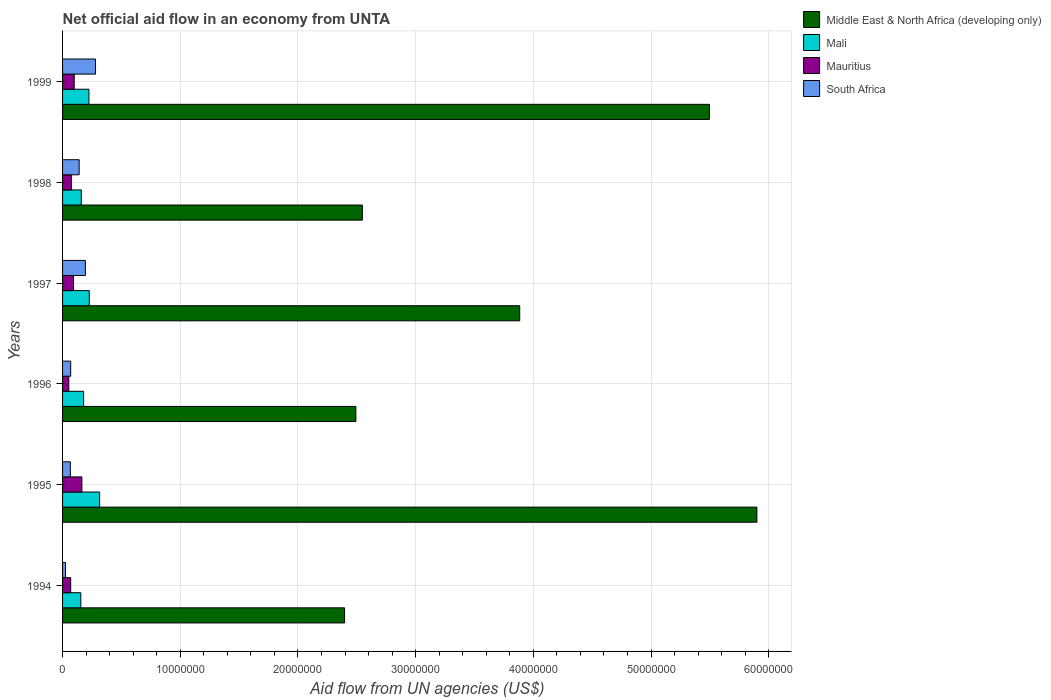How many groups of bars are there?
Your answer should be very brief. 6. Are the number of bars per tick equal to the number of legend labels?
Your answer should be compact. Yes. Are the number of bars on each tick of the Y-axis equal?
Your response must be concise. Yes. How many bars are there on the 4th tick from the top?
Ensure brevity in your answer.  4. In how many cases, is the number of bars for a given year not equal to the number of legend labels?
Provide a short and direct response. 0. What is the net official aid flow in Middle East & North Africa (developing only) in 1994?
Keep it short and to the point. 2.40e+07. Across all years, what is the maximum net official aid flow in South Africa?
Give a very brief answer. 2.80e+06. Across all years, what is the minimum net official aid flow in Mali?
Keep it short and to the point. 1.55e+06. In which year was the net official aid flow in Middle East & North Africa (developing only) maximum?
Make the answer very short. 1995. What is the total net official aid flow in Mauritius in the graph?
Offer a very short reply. 5.53e+06. What is the difference between the net official aid flow in South Africa in 1994 and that in 1998?
Ensure brevity in your answer.  -1.16e+06. What is the difference between the net official aid flow in Mauritius in 1996 and the net official aid flow in South Africa in 1999?
Your answer should be compact. -2.27e+06. What is the average net official aid flow in Middle East & North Africa (developing only) per year?
Provide a succinct answer. 3.79e+07. In the year 1996, what is the difference between the net official aid flow in Middle East & North Africa (developing only) and net official aid flow in South Africa?
Ensure brevity in your answer.  2.42e+07. What is the ratio of the net official aid flow in Mauritius in 1995 to that in 1997?
Provide a succinct answer. 1.76. Is the net official aid flow in Mauritius in 1994 less than that in 1998?
Give a very brief answer. Yes. What is the difference between the highest and the second highest net official aid flow in Middle East & North Africa (developing only)?
Your answer should be compact. 4.03e+06. What is the difference between the highest and the lowest net official aid flow in Mali?
Your answer should be compact. 1.60e+06. In how many years, is the net official aid flow in Middle East & North Africa (developing only) greater than the average net official aid flow in Middle East & North Africa (developing only) taken over all years?
Provide a succinct answer. 3. What does the 1st bar from the top in 1999 represents?
Keep it short and to the point. South Africa. What does the 4th bar from the bottom in 1999 represents?
Offer a very short reply. South Africa. How many years are there in the graph?
Offer a very short reply. 6. What is the difference between two consecutive major ticks on the X-axis?
Give a very brief answer. 1.00e+07. Are the values on the major ticks of X-axis written in scientific E-notation?
Keep it short and to the point. No. How many legend labels are there?
Provide a succinct answer. 4. How are the legend labels stacked?
Provide a short and direct response. Vertical. What is the title of the graph?
Make the answer very short. Net official aid flow in an economy from UNTA. What is the label or title of the X-axis?
Provide a succinct answer. Aid flow from UN agencies (US$). What is the label or title of the Y-axis?
Your answer should be very brief. Years. What is the Aid flow from UN agencies (US$) of Middle East & North Africa (developing only) in 1994?
Give a very brief answer. 2.40e+07. What is the Aid flow from UN agencies (US$) in Mali in 1994?
Provide a succinct answer. 1.55e+06. What is the Aid flow from UN agencies (US$) of Mauritius in 1994?
Make the answer very short. 6.90e+05. What is the Aid flow from UN agencies (US$) of South Africa in 1994?
Provide a succinct answer. 2.50e+05. What is the Aid flow from UN agencies (US$) in Middle East & North Africa (developing only) in 1995?
Make the answer very short. 5.90e+07. What is the Aid flow from UN agencies (US$) in Mali in 1995?
Keep it short and to the point. 3.15e+06. What is the Aid flow from UN agencies (US$) in Mauritius in 1995?
Provide a short and direct response. 1.64e+06. What is the Aid flow from UN agencies (US$) in South Africa in 1995?
Your answer should be compact. 6.60e+05. What is the Aid flow from UN agencies (US$) in Middle East & North Africa (developing only) in 1996?
Provide a succinct answer. 2.49e+07. What is the Aid flow from UN agencies (US$) in Mali in 1996?
Offer a terse response. 1.79e+06. What is the Aid flow from UN agencies (US$) of Mauritius in 1996?
Give a very brief answer. 5.30e+05. What is the Aid flow from UN agencies (US$) of South Africa in 1996?
Your answer should be very brief. 6.90e+05. What is the Aid flow from UN agencies (US$) of Middle East & North Africa (developing only) in 1997?
Your answer should be very brief. 3.88e+07. What is the Aid flow from UN agencies (US$) of Mali in 1997?
Make the answer very short. 2.27e+06. What is the Aid flow from UN agencies (US$) in Mauritius in 1997?
Keep it short and to the point. 9.30e+05. What is the Aid flow from UN agencies (US$) in South Africa in 1997?
Offer a terse response. 1.94e+06. What is the Aid flow from UN agencies (US$) of Middle East & North Africa (developing only) in 1998?
Keep it short and to the point. 2.55e+07. What is the Aid flow from UN agencies (US$) of Mali in 1998?
Provide a succinct answer. 1.59e+06. What is the Aid flow from UN agencies (US$) in Mauritius in 1998?
Your answer should be very brief. 7.50e+05. What is the Aid flow from UN agencies (US$) in South Africa in 1998?
Offer a very short reply. 1.41e+06. What is the Aid flow from UN agencies (US$) of Middle East & North Africa (developing only) in 1999?
Offer a very short reply. 5.50e+07. What is the Aid flow from UN agencies (US$) of Mali in 1999?
Make the answer very short. 2.24e+06. What is the Aid flow from UN agencies (US$) of Mauritius in 1999?
Provide a succinct answer. 9.90e+05. What is the Aid flow from UN agencies (US$) of South Africa in 1999?
Your answer should be compact. 2.80e+06. Across all years, what is the maximum Aid flow from UN agencies (US$) of Middle East & North Africa (developing only)?
Ensure brevity in your answer.  5.90e+07. Across all years, what is the maximum Aid flow from UN agencies (US$) in Mali?
Offer a very short reply. 3.15e+06. Across all years, what is the maximum Aid flow from UN agencies (US$) of Mauritius?
Offer a very short reply. 1.64e+06. Across all years, what is the maximum Aid flow from UN agencies (US$) of South Africa?
Your response must be concise. 2.80e+06. Across all years, what is the minimum Aid flow from UN agencies (US$) of Middle East & North Africa (developing only)?
Your response must be concise. 2.40e+07. Across all years, what is the minimum Aid flow from UN agencies (US$) of Mali?
Give a very brief answer. 1.55e+06. Across all years, what is the minimum Aid flow from UN agencies (US$) of Mauritius?
Make the answer very short. 5.30e+05. Across all years, what is the minimum Aid flow from UN agencies (US$) in South Africa?
Provide a succinct answer. 2.50e+05. What is the total Aid flow from UN agencies (US$) in Middle East & North Africa (developing only) in the graph?
Ensure brevity in your answer.  2.27e+08. What is the total Aid flow from UN agencies (US$) of Mali in the graph?
Your answer should be compact. 1.26e+07. What is the total Aid flow from UN agencies (US$) of Mauritius in the graph?
Provide a short and direct response. 5.53e+06. What is the total Aid flow from UN agencies (US$) of South Africa in the graph?
Your answer should be compact. 7.75e+06. What is the difference between the Aid flow from UN agencies (US$) of Middle East & North Africa (developing only) in 1994 and that in 1995?
Make the answer very short. -3.50e+07. What is the difference between the Aid flow from UN agencies (US$) of Mali in 1994 and that in 1995?
Your answer should be very brief. -1.60e+06. What is the difference between the Aid flow from UN agencies (US$) in Mauritius in 1994 and that in 1995?
Make the answer very short. -9.50e+05. What is the difference between the Aid flow from UN agencies (US$) in South Africa in 1994 and that in 1995?
Your answer should be very brief. -4.10e+05. What is the difference between the Aid flow from UN agencies (US$) in Middle East & North Africa (developing only) in 1994 and that in 1996?
Offer a terse response. -9.60e+05. What is the difference between the Aid flow from UN agencies (US$) in Mali in 1994 and that in 1996?
Your answer should be compact. -2.40e+05. What is the difference between the Aid flow from UN agencies (US$) in Mauritius in 1994 and that in 1996?
Give a very brief answer. 1.60e+05. What is the difference between the Aid flow from UN agencies (US$) of South Africa in 1994 and that in 1996?
Offer a very short reply. -4.40e+05. What is the difference between the Aid flow from UN agencies (US$) of Middle East & North Africa (developing only) in 1994 and that in 1997?
Keep it short and to the point. -1.49e+07. What is the difference between the Aid flow from UN agencies (US$) of Mali in 1994 and that in 1997?
Your answer should be compact. -7.20e+05. What is the difference between the Aid flow from UN agencies (US$) of South Africa in 1994 and that in 1997?
Provide a succinct answer. -1.69e+06. What is the difference between the Aid flow from UN agencies (US$) of Middle East & North Africa (developing only) in 1994 and that in 1998?
Keep it short and to the point. -1.51e+06. What is the difference between the Aid flow from UN agencies (US$) in South Africa in 1994 and that in 1998?
Offer a very short reply. -1.16e+06. What is the difference between the Aid flow from UN agencies (US$) of Middle East & North Africa (developing only) in 1994 and that in 1999?
Keep it short and to the point. -3.10e+07. What is the difference between the Aid flow from UN agencies (US$) in Mali in 1994 and that in 1999?
Provide a short and direct response. -6.90e+05. What is the difference between the Aid flow from UN agencies (US$) of South Africa in 1994 and that in 1999?
Offer a terse response. -2.55e+06. What is the difference between the Aid flow from UN agencies (US$) of Middle East & North Africa (developing only) in 1995 and that in 1996?
Provide a short and direct response. 3.41e+07. What is the difference between the Aid flow from UN agencies (US$) of Mali in 1995 and that in 1996?
Offer a very short reply. 1.36e+06. What is the difference between the Aid flow from UN agencies (US$) in Mauritius in 1995 and that in 1996?
Provide a short and direct response. 1.11e+06. What is the difference between the Aid flow from UN agencies (US$) in Middle East & North Africa (developing only) in 1995 and that in 1997?
Give a very brief answer. 2.02e+07. What is the difference between the Aid flow from UN agencies (US$) in Mali in 1995 and that in 1997?
Provide a short and direct response. 8.80e+05. What is the difference between the Aid flow from UN agencies (US$) of Mauritius in 1995 and that in 1997?
Your response must be concise. 7.10e+05. What is the difference between the Aid flow from UN agencies (US$) in South Africa in 1995 and that in 1997?
Keep it short and to the point. -1.28e+06. What is the difference between the Aid flow from UN agencies (US$) of Middle East & North Africa (developing only) in 1995 and that in 1998?
Make the answer very short. 3.35e+07. What is the difference between the Aid flow from UN agencies (US$) of Mali in 1995 and that in 1998?
Offer a terse response. 1.56e+06. What is the difference between the Aid flow from UN agencies (US$) of Mauritius in 1995 and that in 1998?
Offer a very short reply. 8.90e+05. What is the difference between the Aid flow from UN agencies (US$) in South Africa in 1995 and that in 1998?
Make the answer very short. -7.50e+05. What is the difference between the Aid flow from UN agencies (US$) in Middle East & North Africa (developing only) in 1995 and that in 1999?
Your response must be concise. 4.03e+06. What is the difference between the Aid flow from UN agencies (US$) in Mali in 1995 and that in 1999?
Your response must be concise. 9.10e+05. What is the difference between the Aid flow from UN agencies (US$) of Mauritius in 1995 and that in 1999?
Provide a short and direct response. 6.50e+05. What is the difference between the Aid flow from UN agencies (US$) in South Africa in 1995 and that in 1999?
Provide a succinct answer. -2.14e+06. What is the difference between the Aid flow from UN agencies (US$) in Middle East & North Africa (developing only) in 1996 and that in 1997?
Provide a succinct answer. -1.39e+07. What is the difference between the Aid flow from UN agencies (US$) in Mali in 1996 and that in 1997?
Your answer should be compact. -4.80e+05. What is the difference between the Aid flow from UN agencies (US$) in Mauritius in 1996 and that in 1997?
Your response must be concise. -4.00e+05. What is the difference between the Aid flow from UN agencies (US$) of South Africa in 1996 and that in 1997?
Your answer should be compact. -1.25e+06. What is the difference between the Aid flow from UN agencies (US$) of Middle East & North Africa (developing only) in 1996 and that in 1998?
Your response must be concise. -5.50e+05. What is the difference between the Aid flow from UN agencies (US$) of Mauritius in 1996 and that in 1998?
Your answer should be compact. -2.20e+05. What is the difference between the Aid flow from UN agencies (US$) of South Africa in 1996 and that in 1998?
Give a very brief answer. -7.20e+05. What is the difference between the Aid flow from UN agencies (US$) of Middle East & North Africa (developing only) in 1996 and that in 1999?
Provide a succinct answer. -3.00e+07. What is the difference between the Aid flow from UN agencies (US$) in Mali in 1996 and that in 1999?
Your response must be concise. -4.50e+05. What is the difference between the Aid flow from UN agencies (US$) of Mauritius in 1996 and that in 1999?
Your response must be concise. -4.60e+05. What is the difference between the Aid flow from UN agencies (US$) of South Africa in 1996 and that in 1999?
Ensure brevity in your answer.  -2.11e+06. What is the difference between the Aid flow from UN agencies (US$) of Middle East & North Africa (developing only) in 1997 and that in 1998?
Offer a very short reply. 1.34e+07. What is the difference between the Aid flow from UN agencies (US$) of Mali in 1997 and that in 1998?
Ensure brevity in your answer.  6.80e+05. What is the difference between the Aid flow from UN agencies (US$) in Mauritius in 1997 and that in 1998?
Offer a very short reply. 1.80e+05. What is the difference between the Aid flow from UN agencies (US$) in South Africa in 1997 and that in 1998?
Your response must be concise. 5.30e+05. What is the difference between the Aid flow from UN agencies (US$) in Middle East & North Africa (developing only) in 1997 and that in 1999?
Ensure brevity in your answer.  -1.61e+07. What is the difference between the Aid flow from UN agencies (US$) in Mauritius in 1997 and that in 1999?
Offer a very short reply. -6.00e+04. What is the difference between the Aid flow from UN agencies (US$) in South Africa in 1997 and that in 1999?
Keep it short and to the point. -8.60e+05. What is the difference between the Aid flow from UN agencies (US$) in Middle East & North Africa (developing only) in 1998 and that in 1999?
Offer a very short reply. -2.95e+07. What is the difference between the Aid flow from UN agencies (US$) in Mali in 1998 and that in 1999?
Give a very brief answer. -6.50e+05. What is the difference between the Aid flow from UN agencies (US$) of Mauritius in 1998 and that in 1999?
Make the answer very short. -2.40e+05. What is the difference between the Aid flow from UN agencies (US$) of South Africa in 1998 and that in 1999?
Your answer should be very brief. -1.39e+06. What is the difference between the Aid flow from UN agencies (US$) of Middle East & North Africa (developing only) in 1994 and the Aid flow from UN agencies (US$) of Mali in 1995?
Give a very brief answer. 2.08e+07. What is the difference between the Aid flow from UN agencies (US$) in Middle East & North Africa (developing only) in 1994 and the Aid flow from UN agencies (US$) in Mauritius in 1995?
Offer a very short reply. 2.23e+07. What is the difference between the Aid flow from UN agencies (US$) of Middle East & North Africa (developing only) in 1994 and the Aid flow from UN agencies (US$) of South Africa in 1995?
Offer a terse response. 2.33e+07. What is the difference between the Aid flow from UN agencies (US$) in Mali in 1994 and the Aid flow from UN agencies (US$) in South Africa in 1995?
Ensure brevity in your answer.  8.90e+05. What is the difference between the Aid flow from UN agencies (US$) of Middle East & North Africa (developing only) in 1994 and the Aid flow from UN agencies (US$) of Mali in 1996?
Give a very brief answer. 2.22e+07. What is the difference between the Aid flow from UN agencies (US$) in Middle East & North Africa (developing only) in 1994 and the Aid flow from UN agencies (US$) in Mauritius in 1996?
Your answer should be compact. 2.34e+07. What is the difference between the Aid flow from UN agencies (US$) in Middle East & North Africa (developing only) in 1994 and the Aid flow from UN agencies (US$) in South Africa in 1996?
Make the answer very short. 2.33e+07. What is the difference between the Aid flow from UN agencies (US$) in Mali in 1994 and the Aid flow from UN agencies (US$) in Mauritius in 1996?
Provide a short and direct response. 1.02e+06. What is the difference between the Aid flow from UN agencies (US$) in Mali in 1994 and the Aid flow from UN agencies (US$) in South Africa in 1996?
Your answer should be compact. 8.60e+05. What is the difference between the Aid flow from UN agencies (US$) of Middle East & North Africa (developing only) in 1994 and the Aid flow from UN agencies (US$) of Mali in 1997?
Offer a terse response. 2.17e+07. What is the difference between the Aid flow from UN agencies (US$) in Middle East & North Africa (developing only) in 1994 and the Aid flow from UN agencies (US$) in Mauritius in 1997?
Your response must be concise. 2.30e+07. What is the difference between the Aid flow from UN agencies (US$) of Middle East & North Africa (developing only) in 1994 and the Aid flow from UN agencies (US$) of South Africa in 1997?
Your response must be concise. 2.20e+07. What is the difference between the Aid flow from UN agencies (US$) in Mali in 1994 and the Aid flow from UN agencies (US$) in Mauritius in 1997?
Your answer should be compact. 6.20e+05. What is the difference between the Aid flow from UN agencies (US$) in Mali in 1994 and the Aid flow from UN agencies (US$) in South Africa in 1997?
Your answer should be very brief. -3.90e+05. What is the difference between the Aid flow from UN agencies (US$) in Mauritius in 1994 and the Aid flow from UN agencies (US$) in South Africa in 1997?
Keep it short and to the point. -1.25e+06. What is the difference between the Aid flow from UN agencies (US$) in Middle East & North Africa (developing only) in 1994 and the Aid flow from UN agencies (US$) in Mali in 1998?
Offer a terse response. 2.24e+07. What is the difference between the Aid flow from UN agencies (US$) of Middle East & North Africa (developing only) in 1994 and the Aid flow from UN agencies (US$) of Mauritius in 1998?
Your response must be concise. 2.32e+07. What is the difference between the Aid flow from UN agencies (US$) in Middle East & North Africa (developing only) in 1994 and the Aid flow from UN agencies (US$) in South Africa in 1998?
Provide a succinct answer. 2.26e+07. What is the difference between the Aid flow from UN agencies (US$) in Mali in 1994 and the Aid flow from UN agencies (US$) in Mauritius in 1998?
Provide a short and direct response. 8.00e+05. What is the difference between the Aid flow from UN agencies (US$) of Mali in 1994 and the Aid flow from UN agencies (US$) of South Africa in 1998?
Give a very brief answer. 1.40e+05. What is the difference between the Aid flow from UN agencies (US$) in Mauritius in 1994 and the Aid flow from UN agencies (US$) in South Africa in 1998?
Give a very brief answer. -7.20e+05. What is the difference between the Aid flow from UN agencies (US$) of Middle East & North Africa (developing only) in 1994 and the Aid flow from UN agencies (US$) of Mali in 1999?
Your answer should be compact. 2.17e+07. What is the difference between the Aid flow from UN agencies (US$) in Middle East & North Africa (developing only) in 1994 and the Aid flow from UN agencies (US$) in Mauritius in 1999?
Ensure brevity in your answer.  2.30e+07. What is the difference between the Aid flow from UN agencies (US$) of Middle East & North Africa (developing only) in 1994 and the Aid flow from UN agencies (US$) of South Africa in 1999?
Your answer should be compact. 2.12e+07. What is the difference between the Aid flow from UN agencies (US$) of Mali in 1994 and the Aid flow from UN agencies (US$) of Mauritius in 1999?
Provide a succinct answer. 5.60e+05. What is the difference between the Aid flow from UN agencies (US$) of Mali in 1994 and the Aid flow from UN agencies (US$) of South Africa in 1999?
Make the answer very short. -1.25e+06. What is the difference between the Aid flow from UN agencies (US$) in Mauritius in 1994 and the Aid flow from UN agencies (US$) in South Africa in 1999?
Your response must be concise. -2.11e+06. What is the difference between the Aid flow from UN agencies (US$) of Middle East & North Africa (developing only) in 1995 and the Aid flow from UN agencies (US$) of Mali in 1996?
Offer a very short reply. 5.72e+07. What is the difference between the Aid flow from UN agencies (US$) of Middle East & North Africa (developing only) in 1995 and the Aid flow from UN agencies (US$) of Mauritius in 1996?
Offer a very short reply. 5.85e+07. What is the difference between the Aid flow from UN agencies (US$) in Middle East & North Africa (developing only) in 1995 and the Aid flow from UN agencies (US$) in South Africa in 1996?
Give a very brief answer. 5.83e+07. What is the difference between the Aid flow from UN agencies (US$) in Mali in 1995 and the Aid flow from UN agencies (US$) in Mauritius in 1996?
Ensure brevity in your answer.  2.62e+06. What is the difference between the Aid flow from UN agencies (US$) of Mali in 1995 and the Aid flow from UN agencies (US$) of South Africa in 1996?
Make the answer very short. 2.46e+06. What is the difference between the Aid flow from UN agencies (US$) in Mauritius in 1995 and the Aid flow from UN agencies (US$) in South Africa in 1996?
Your answer should be compact. 9.50e+05. What is the difference between the Aid flow from UN agencies (US$) in Middle East & North Africa (developing only) in 1995 and the Aid flow from UN agencies (US$) in Mali in 1997?
Provide a succinct answer. 5.67e+07. What is the difference between the Aid flow from UN agencies (US$) in Middle East & North Africa (developing only) in 1995 and the Aid flow from UN agencies (US$) in Mauritius in 1997?
Your answer should be compact. 5.81e+07. What is the difference between the Aid flow from UN agencies (US$) of Middle East & North Africa (developing only) in 1995 and the Aid flow from UN agencies (US$) of South Africa in 1997?
Give a very brief answer. 5.70e+07. What is the difference between the Aid flow from UN agencies (US$) of Mali in 1995 and the Aid flow from UN agencies (US$) of Mauritius in 1997?
Your answer should be very brief. 2.22e+06. What is the difference between the Aid flow from UN agencies (US$) of Mali in 1995 and the Aid flow from UN agencies (US$) of South Africa in 1997?
Make the answer very short. 1.21e+06. What is the difference between the Aid flow from UN agencies (US$) in Middle East & North Africa (developing only) in 1995 and the Aid flow from UN agencies (US$) in Mali in 1998?
Offer a terse response. 5.74e+07. What is the difference between the Aid flow from UN agencies (US$) of Middle East & North Africa (developing only) in 1995 and the Aid flow from UN agencies (US$) of Mauritius in 1998?
Your answer should be very brief. 5.82e+07. What is the difference between the Aid flow from UN agencies (US$) in Middle East & North Africa (developing only) in 1995 and the Aid flow from UN agencies (US$) in South Africa in 1998?
Your answer should be very brief. 5.76e+07. What is the difference between the Aid flow from UN agencies (US$) in Mali in 1995 and the Aid flow from UN agencies (US$) in Mauritius in 1998?
Your response must be concise. 2.40e+06. What is the difference between the Aid flow from UN agencies (US$) in Mali in 1995 and the Aid flow from UN agencies (US$) in South Africa in 1998?
Keep it short and to the point. 1.74e+06. What is the difference between the Aid flow from UN agencies (US$) in Middle East & North Africa (developing only) in 1995 and the Aid flow from UN agencies (US$) in Mali in 1999?
Your answer should be very brief. 5.68e+07. What is the difference between the Aid flow from UN agencies (US$) of Middle East & North Africa (developing only) in 1995 and the Aid flow from UN agencies (US$) of Mauritius in 1999?
Your answer should be compact. 5.80e+07. What is the difference between the Aid flow from UN agencies (US$) in Middle East & North Africa (developing only) in 1995 and the Aid flow from UN agencies (US$) in South Africa in 1999?
Ensure brevity in your answer.  5.62e+07. What is the difference between the Aid flow from UN agencies (US$) in Mali in 1995 and the Aid flow from UN agencies (US$) in Mauritius in 1999?
Provide a short and direct response. 2.16e+06. What is the difference between the Aid flow from UN agencies (US$) in Mauritius in 1995 and the Aid flow from UN agencies (US$) in South Africa in 1999?
Ensure brevity in your answer.  -1.16e+06. What is the difference between the Aid flow from UN agencies (US$) in Middle East & North Africa (developing only) in 1996 and the Aid flow from UN agencies (US$) in Mali in 1997?
Your response must be concise. 2.26e+07. What is the difference between the Aid flow from UN agencies (US$) in Middle East & North Africa (developing only) in 1996 and the Aid flow from UN agencies (US$) in Mauritius in 1997?
Keep it short and to the point. 2.40e+07. What is the difference between the Aid flow from UN agencies (US$) in Middle East & North Africa (developing only) in 1996 and the Aid flow from UN agencies (US$) in South Africa in 1997?
Provide a succinct answer. 2.30e+07. What is the difference between the Aid flow from UN agencies (US$) in Mali in 1996 and the Aid flow from UN agencies (US$) in Mauritius in 1997?
Offer a very short reply. 8.60e+05. What is the difference between the Aid flow from UN agencies (US$) in Mauritius in 1996 and the Aid flow from UN agencies (US$) in South Africa in 1997?
Keep it short and to the point. -1.41e+06. What is the difference between the Aid flow from UN agencies (US$) of Middle East & North Africa (developing only) in 1996 and the Aid flow from UN agencies (US$) of Mali in 1998?
Ensure brevity in your answer.  2.33e+07. What is the difference between the Aid flow from UN agencies (US$) in Middle East & North Africa (developing only) in 1996 and the Aid flow from UN agencies (US$) in Mauritius in 1998?
Provide a succinct answer. 2.42e+07. What is the difference between the Aid flow from UN agencies (US$) in Middle East & North Africa (developing only) in 1996 and the Aid flow from UN agencies (US$) in South Africa in 1998?
Give a very brief answer. 2.35e+07. What is the difference between the Aid flow from UN agencies (US$) of Mali in 1996 and the Aid flow from UN agencies (US$) of Mauritius in 1998?
Make the answer very short. 1.04e+06. What is the difference between the Aid flow from UN agencies (US$) of Mali in 1996 and the Aid flow from UN agencies (US$) of South Africa in 1998?
Offer a terse response. 3.80e+05. What is the difference between the Aid flow from UN agencies (US$) in Mauritius in 1996 and the Aid flow from UN agencies (US$) in South Africa in 1998?
Give a very brief answer. -8.80e+05. What is the difference between the Aid flow from UN agencies (US$) in Middle East & North Africa (developing only) in 1996 and the Aid flow from UN agencies (US$) in Mali in 1999?
Provide a succinct answer. 2.27e+07. What is the difference between the Aid flow from UN agencies (US$) of Middle East & North Africa (developing only) in 1996 and the Aid flow from UN agencies (US$) of Mauritius in 1999?
Your answer should be compact. 2.39e+07. What is the difference between the Aid flow from UN agencies (US$) of Middle East & North Africa (developing only) in 1996 and the Aid flow from UN agencies (US$) of South Africa in 1999?
Keep it short and to the point. 2.21e+07. What is the difference between the Aid flow from UN agencies (US$) of Mali in 1996 and the Aid flow from UN agencies (US$) of South Africa in 1999?
Your answer should be compact. -1.01e+06. What is the difference between the Aid flow from UN agencies (US$) in Mauritius in 1996 and the Aid flow from UN agencies (US$) in South Africa in 1999?
Your response must be concise. -2.27e+06. What is the difference between the Aid flow from UN agencies (US$) in Middle East & North Africa (developing only) in 1997 and the Aid flow from UN agencies (US$) in Mali in 1998?
Provide a succinct answer. 3.72e+07. What is the difference between the Aid flow from UN agencies (US$) of Middle East & North Africa (developing only) in 1997 and the Aid flow from UN agencies (US$) of Mauritius in 1998?
Give a very brief answer. 3.81e+07. What is the difference between the Aid flow from UN agencies (US$) in Middle East & North Africa (developing only) in 1997 and the Aid flow from UN agencies (US$) in South Africa in 1998?
Offer a very short reply. 3.74e+07. What is the difference between the Aid flow from UN agencies (US$) in Mali in 1997 and the Aid flow from UN agencies (US$) in Mauritius in 1998?
Make the answer very short. 1.52e+06. What is the difference between the Aid flow from UN agencies (US$) in Mali in 1997 and the Aid flow from UN agencies (US$) in South Africa in 1998?
Provide a succinct answer. 8.60e+05. What is the difference between the Aid flow from UN agencies (US$) of Mauritius in 1997 and the Aid flow from UN agencies (US$) of South Africa in 1998?
Ensure brevity in your answer.  -4.80e+05. What is the difference between the Aid flow from UN agencies (US$) of Middle East & North Africa (developing only) in 1997 and the Aid flow from UN agencies (US$) of Mali in 1999?
Ensure brevity in your answer.  3.66e+07. What is the difference between the Aid flow from UN agencies (US$) in Middle East & North Africa (developing only) in 1997 and the Aid flow from UN agencies (US$) in Mauritius in 1999?
Provide a short and direct response. 3.78e+07. What is the difference between the Aid flow from UN agencies (US$) of Middle East & North Africa (developing only) in 1997 and the Aid flow from UN agencies (US$) of South Africa in 1999?
Your answer should be compact. 3.60e+07. What is the difference between the Aid flow from UN agencies (US$) in Mali in 1997 and the Aid flow from UN agencies (US$) in Mauritius in 1999?
Your response must be concise. 1.28e+06. What is the difference between the Aid flow from UN agencies (US$) of Mali in 1997 and the Aid flow from UN agencies (US$) of South Africa in 1999?
Provide a succinct answer. -5.30e+05. What is the difference between the Aid flow from UN agencies (US$) of Mauritius in 1997 and the Aid flow from UN agencies (US$) of South Africa in 1999?
Offer a very short reply. -1.87e+06. What is the difference between the Aid flow from UN agencies (US$) in Middle East & North Africa (developing only) in 1998 and the Aid flow from UN agencies (US$) in Mali in 1999?
Your answer should be very brief. 2.32e+07. What is the difference between the Aid flow from UN agencies (US$) in Middle East & North Africa (developing only) in 1998 and the Aid flow from UN agencies (US$) in Mauritius in 1999?
Your answer should be very brief. 2.45e+07. What is the difference between the Aid flow from UN agencies (US$) in Middle East & North Africa (developing only) in 1998 and the Aid flow from UN agencies (US$) in South Africa in 1999?
Your response must be concise. 2.27e+07. What is the difference between the Aid flow from UN agencies (US$) in Mali in 1998 and the Aid flow from UN agencies (US$) in Mauritius in 1999?
Give a very brief answer. 6.00e+05. What is the difference between the Aid flow from UN agencies (US$) of Mali in 1998 and the Aid flow from UN agencies (US$) of South Africa in 1999?
Provide a succinct answer. -1.21e+06. What is the difference between the Aid flow from UN agencies (US$) of Mauritius in 1998 and the Aid flow from UN agencies (US$) of South Africa in 1999?
Give a very brief answer. -2.05e+06. What is the average Aid flow from UN agencies (US$) of Middle East & North Africa (developing only) per year?
Your response must be concise. 3.79e+07. What is the average Aid flow from UN agencies (US$) in Mali per year?
Your response must be concise. 2.10e+06. What is the average Aid flow from UN agencies (US$) in Mauritius per year?
Keep it short and to the point. 9.22e+05. What is the average Aid flow from UN agencies (US$) in South Africa per year?
Your answer should be very brief. 1.29e+06. In the year 1994, what is the difference between the Aid flow from UN agencies (US$) of Middle East & North Africa (developing only) and Aid flow from UN agencies (US$) of Mali?
Ensure brevity in your answer.  2.24e+07. In the year 1994, what is the difference between the Aid flow from UN agencies (US$) in Middle East & North Africa (developing only) and Aid flow from UN agencies (US$) in Mauritius?
Offer a terse response. 2.33e+07. In the year 1994, what is the difference between the Aid flow from UN agencies (US$) of Middle East & North Africa (developing only) and Aid flow from UN agencies (US$) of South Africa?
Give a very brief answer. 2.37e+07. In the year 1994, what is the difference between the Aid flow from UN agencies (US$) in Mali and Aid flow from UN agencies (US$) in Mauritius?
Provide a short and direct response. 8.60e+05. In the year 1994, what is the difference between the Aid flow from UN agencies (US$) in Mali and Aid flow from UN agencies (US$) in South Africa?
Your answer should be compact. 1.30e+06. In the year 1995, what is the difference between the Aid flow from UN agencies (US$) in Middle East & North Africa (developing only) and Aid flow from UN agencies (US$) in Mali?
Offer a terse response. 5.58e+07. In the year 1995, what is the difference between the Aid flow from UN agencies (US$) in Middle East & North Africa (developing only) and Aid flow from UN agencies (US$) in Mauritius?
Give a very brief answer. 5.74e+07. In the year 1995, what is the difference between the Aid flow from UN agencies (US$) of Middle East & North Africa (developing only) and Aid flow from UN agencies (US$) of South Africa?
Your answer should be very brief. 5.83e+07. In the year 1995, what is the difference between the Aid flow from UN agencies (US$) in Mali and Aid flow from UN agencies (US$) in Mauritius?
Provide a succinct answer. 1.51e+06. In the year 1995, what is the difference between the Aid flow from UN agencies (US$) of Mali and Aid flow from UN agencies (US$) of South Africa?
Offer a very short reply. 2.49e+06. In the year 1995, what is the difference between the Aid flow from UN agencies (US$) in Mauritius and Aid flow from UN agencies (US$) in South Africa?
Your answer should be compact. 9.80e+05. In the year 1996, what is the difference between the Aid flow from UN agencies (US$) in Middle East & North Africa (developing only) and Aid flow from UN agencies (US$) in Mali?
Provide a succinct answer. 2.31e+07. In the year 1996, what is the difference between the Aid flow from UN agencies (US$) of Middle East & North Africa (developing only) and Aid flow from UN agencies (US$) of Mauritius?
Give a very brief answer. 2.44e+07. In the year 1996, what is the difference between the Aid flow from UN agencies (US$) in Middle East & North Africa (developing only) and Aid flow from UN agencies (US$) in South Africa?
Ensure brevity in your answer.  2.42e+07. In the year 1996, what is the difference between the Aid flow from UN agencies (US$) of Mali and Aid flow from UN agencies (US$) of Mauritius?
Your response must be concise. 1.26e+06. In the year 1996, what is the difference between the Aid flow from UN agencies (US$) in Mali and Aid flow from UN agencies (US$) in South Africa?
Provide a succinct answer. 1.10e+06. In the year 1996, what is the difference between the Aid flow from UN agencies (US$) of Mauritius and Aid flow from UN agencies (US$) of South Africa?
Make the answer very short. -1.60e+05. In the year 1997, what is the difference between the Aid flow from UN agencies (US$) of Middle East & North Africa (developing only) and Aid flow from UN agencies (US$) of Mali?
Your answer should be very brief. 3.66e+07. In the year 1997, what is the difference between the Aid flow from UN agencies (US$) in Middle East & North Africa (developing only) and Aid flow from UN agencies (US$) in Mauritius?
Provide a short and direct response. 3.79e+07. In the year 1997, what is the difference between the Aid flow from UN agencies (US$) in Middle East & North Africa (developing only) and Aid flow from UN agencies (US$) in South Africa?
Your answer should be very brief. 3.69e+07. In the year 1997, what is the difference between the Aid flow from UN agencies (US$) of Mali and Aid flow from UN agencies (US$) of Mauritius?
Your answer should be very brief. 1.34e+06. In the year 1997, what is the difference between the Aid flow from UN agencies (US$) of Mali and Aid flow from UN agencies (US$) of South Africa?
Ensure brevity in your answer.  3.30e+05. In the year 1997, what is the difference between the Aid flow from UN agencies (US$) of Mauritius and Aid flow from UN agencies (US$) of South Africa?
Provide a short and direct response. -1.01e+06. In the year 1998, what is the difference between the Aid flow from UN agencies (US$) of Middle East & North Africa (developing only) and Aid flow from UN agencies (US$) of Mali?
Make the answer very short. 2.39e+07. In the year 1998, what is the difference between the Aid flow from UN agencies (US$) in Middle East & North Africa (developing only) and Aid flow from UN agencies (US$) in Mauritius?
Give a very brief answer. 2.47e+07. In the year 1998, what is the difference between the Aid flow from UN agencies (US$) of Middle East & North Africa (developing only) and Aid flow from UN agencies (US$) of South Africa?
Give a very brief answer. 2.41e+07. In the year 1998, what is the difference between the Aid flow from UN agencies (US$) in Mali and Aid flow from UN agencies (US$) in Mauritius?
Offer a very short reply. 8.40e+05. In the year 1998, what is the difference between the Aid flow from UN agencies (US$) of Mali and Aid flow from UN agencies (US$) of South Africa?
Your response must be concise. 1.80e+05. In the year 1998, what is the difference between the Aid flow from UN agencies (US$) of Mauritius and Aid flow from UN agencies (US$) of South Africa?
Ensure brevity in your answer.  -6.60e+05. In the year 1999, what is the difference between the Aid flow from UN agencies (US$) in Middle East & North Africa (developing only) and Aid flow from UN agencies (US$) in Mali?
Offer a very short reply. 5.27e+07. In the year 1999, what is the difference between the Aid flow from UN agencies (US$) in Middle East & North Africa (developing only) and Aid flow from UN agencies (US$) in Mauritius?
Provide a short and direct response. 5.40e+07. In the year 1999, what is the difference between the Aid flow from UN agencies (US$) in Middle East & North Africa (developing only) and Aid flow from UN agencies (US$) in South Africa?
Offer a very short reply. 5.22e+07. In the year 1999, what is the difference between the Aid flow from UN agencies (US$) of Mali and Aid flow from UN agencies (US$) of Mauritius?
Provide a short and direct response. 1.25e+06. In the year 1999, what is the difference between the Aid flow from UN agencies (US$) of Mali and Aid flow from UN agencies (US$) of South Africa?
Provide a short and direct response. -5.60e+05. In the year 1999, what is the difference between the Aid flow from UN agencies (US$) of Mauritius and Aid flow from UN agencies (US$) of South Africa?
Give a very brief answer. -1.81e+06. What is the ratio of the Aid flow from UN agencies (US$) in Middle East & North Africa (developing only) in 1994 to that in 1995?
Your answer should be compact. 0.41. What is the ratio of the Aid flow from UN agencies (US$) in Mali in 1994 to that in 1995?
Make the answer very short. 0.49. What is the ratio of the Aid flow from UN agencies (US$) in Mauritius in 1994 to that in 1995?
Your answer should be very brief. 0.42. What is the ratio of the Aid flow from UN agencies (US$) in South Africa in 1994 to that in 1995?
Your answer should be very brief. 0.38. What is the ratio of the Aid flow from UN agencies (US$) in Middle East & North Africa (developing only) in 1994 to that in 1996?
Provide a succinct answer. 0.96. What is the ratio of the Aid flow from UN agencies (US$) of Mali in 1994 to that in 1996?
Keep it short and to the point. 0.87. What is the ratio of the Aid flow from UN agencies (US$) in Mauritius in 1994 to that in 1996?
Give a very brief answer. 1.3. What is the ratio of the Aid flow from UN agencies (US$) of South Africa in 1994 to that in 1996?
Make the answer very short. 0.36. What is the ratio of the Aid flow from UN agencies (US$) in Middle East & North Africa (developing only) in 1994 to that in 1997?
Ensure brevity in your answer.  0.62. What is the ratio of the Aid flow from UN agencies (US$) in Mali in 1994 to that in 1997?
Provide a succinct answer. 0.68. What is the ratio of the Aid flow from UN agencies (US$) in Mauritius in 1994 to that in 1997?
Ensure brevity in your answer.  0.74. What is the ratio of the Aid flow from UN agencies (US$) of South Africa in 1994 to that in 1997?
Offer a terse response. 0.13. What is the ratio of the Aid flow from UN agencies (US$) in Middle East & North Africa (developing only) in 1994 to that in 1998?
Your answer should be very brief. 0.94. What is the ratio of the Aid flow from UN agencies (US$) of Mali in 1994 to that in 1998?
Make the answer very short. 0.97. What is the ratio of the Aid flow from UN agencies (US$) in Mauritius in 1994 to that in 1998?
Ensure brevity in your answer.  0.92. What is the ratio of the Aid flow from UN agencies (US$) of South Africa in 1994 to that in 1998?
Offer a very short reply. 0.18. What is the ratio of the Aid flow from UN agencies (US$) of Middle East & North Africa (developing only) in 1994 to that in 1999?
Your answer should be very brief. 0.44. What is the ratio of the Aid flow from UN agencies (US$) in Mali in 1994 to that in 1999?
Offer a very short reply. 0.69. What is the ratio of the Aid flow from UN agencies (US$) of Mauritius in 1994 to that in 1999?
Provide a short and direct response. 0.7. What is the ratio of the Aid flow from UN agencies (US$) of South Africa in 1994 to that in 1999?
Keep it short and to the point. 0.09. What is the ratio of the Aid flow from UN agencies (US$) in Middle East & North Africa (developing only) in 1995 to that in 1996?
Give a very brief answer. 2.37. What is the ratio of the Aid flow from UN agencies (US$) of Mali in 1995 to that in 1996?
Ensure brevity in your answer.  1.76. What is the ratio of the Aid flow from UN agencies (US$) in Mauritius in 1995 to that in 1996?
Your answer should be compact. 3.09. What is the ratio of the Aid flow from UN agencies (US$) in South Africa in 1995 to that in 1996?
Ensure brevity in your answer.  0.96. What is the ratio of the Aid flow from UN agencies (US$) of Middle East & North Africa (developing only) in 1995 to that in 1997?
Your response must be concise. 1.52. What is the ratio of the Aid flow from UN agencies (US$) in Mali in 1995 to that in 1997?
Your answer should be compact. 1.39. What is the ratio of the Aid flow from UN agencies (US$) of Mauritius in 1995 to that in 1997?
Ensure brevity in your answer.  1.76. What is the ratio of the Aid flow from UN agencies (US$) of South Africa in 1995 to that in 1997?
Your response must be concise. 0.34. What is the ratio of the Aid flow from UN agencies (US$) in Middle East & North Africa (developing only) in 1995 to that in 1998?
Your response must be concise. 2.32. What is the ratio of the Aid flow from UN agencies (US$) in Mali in 1995 to that in 1998?
Provide a succinct answer. 1.98. What is the ratio of the Aid flow from UN agencies (US$) in Mauritius in 1995 to that in 1998?
Keep it short and to the point. 2.19. What is the ratio of the Aid flow from UN agencies (US$) in South Africa in 1995 to that in 1998?
Ensure brevity in your answer.  0.47. What is the ratio of the Aid flow from UN agencies (US$) in Middle East & North Africa (developing only) in 1995 to that in 1999?
Give a very brief answer. 1.07. What is the ratio of the Aid flow from UN agencies (US$) in Mali in 1995 to that in 1999?
Your response must be concise. 1.41. What is the ratio of the Aid flow from UN agencies (US$) of Mauritius in 1995 to that in 1999?
Your answer should be compact. 1.66. What is the ratio of the Aid flow from UN agencies (US$) of South Africa in 1995 to that in 1999?
Offer a very short reply. 0.24. What is the ratio of the Aid flow from UN agencies (US$) in Middle East & North Africa (developing only) in 1996 to that in 1997?
Your response must be concise. 0.64. What is the ratio of the Aid flow from UN agencies (US$) of Mali in 1996 to that in 1997?
Your response must be concise. 0.79. What is the ratio of the Aid flow from UN agencies (US$) of Mauritius in 1996 to that in 1997?
Keep it short and to the point. 0.57. What is the ratio of the Aid flow from UN agencies (US$) of South Africa in 1996 to that in 1997?
Make the answer very short. 0.36. What is the ratio of the Aid flow from UN agencies (US$) of Middle East & North Africa (developing only) in 1996 to that in 1998?
Your answer should be very brief. 0.98. What is the ratio of the Aid flow from UN agencies (US$) of Mali in 1996 to that in 1998?
Ensure brevity in your answer.  1.13. What is the ratio of the Aid flow from UN agencies (US$) of Mauritius in 1996 to that in 1998?
Your answer should be very brief. 0.71. What is the ratio of the Aid flow from UN agencies (US$) of South Africa in 1996 to that in 1998?
Keep it short and to the point. 0.49. What is the ratio of the Aid flow from UN agencies (US$) in Middle East & North Africa (developing only) in 1996 to that in 1999?
Keep it short and to the point. 0.45. What is the ratio of the Aid flow from UN agencies (US$) in Mali in 1996 to that in 1999?
Your response must be concise. 0.8. What is the ratio of the Aid flow from UN agencies (US$) in Mauritius in 1996 to that in 1999?
Offer a very short reply. 0.54. What is the ratio of the Aid flow from UN agencies (US$) of South Africa in 1996 to that in 1999?
Your response must be concise. 0.25. What is the ratio of the Aid flow from UN agencies (US$) of Middle East & North Africa (developing only) in 1997 to that in 1998?
Give a very brief answer. 1.52. What is the ratio of the Aid flow from UN agencies (US$) of Mali in 1997 to that in 1998?
Ensure brevity in your answer.  1.43. What is the ratio of the Aid flow from UN agencies (US$) in Mauritius in 1997 to that in 1998?
Your response must be concise. 1.24. What is the ratio of the Aid flow from UN agencies (US$) of South Africa in 1997 to that in 1998?
Provide a short and direct response. 1.38. What is the ratio of the Aid flow from UN agencies (US$) in Middle East & North Africa (developing only) in 1997 to that in 1999?
Your response must be concise. 0.71. What is the ratio of the Aid flow from UN agencies (US$) in Mali in 1997 to that in 1999?
Ensure brevity in your answer.  1.01. What is the ratio of the Aid flow from UN agencies (US$) in Mauritius in 1997 to that in 1999?
Offer a very short reply. 0.94. What is the ratio of the Aid flow from UN agencies (US$) in South Africa in 1997 to that in 1999?
Offer a terse response. 0.69. What is the ratio of the Aid flow from UN agencies (US$) in Middle East & North Africa (developing only) in 1998 to that in 1999?
Provide a succinct answer. 0.46. What is the ratio of the Aid flow from UN agencies (US$) of Mali in 1998 to that in 1999?
Your answer should be compact. 0.71. What is the ratio of the Aid flow from UN agencies (US$) in Mauritius in 1998 to that in 1999?
Give a very brief answer. 0.76. What is the ratio of the Aid flow from UN agencies (US$) in South Africa in 1998 to that in 1999?
Ensure brevity in your answer.  0.5. What is the difference between the highest and the second highest Aid flow from UN agencies (US$) of Middle East & North Africa (developing only)?
Your response must be concise. 4.03e+06. What is the difference between the highest and the second highest Aid flow from UN agencies (US$) of Mali?
Keep it short and to the point. 8.80e+05. What is the difference between the highest and the second highest Aid flow from UN agencies (US$) in Mauritius?
Ensure brevity in your answer.  6.50e+05. What is the difference between the highest and the second highest Aid flow from UN agencies (US$) of South Africa?
Offer a very short reply. 8.60e+05. What is the difference between the highest and the lowest Aid flow from UN agencies (US$) of Middle East & North Africa (developing only)?
Ensure brevity in your answer.  3.50e+07. What is the difference between the highest and the lowest Aid flow from UN agencies (US$) of Mali?
Give a very brief answer. 1.60e+06. What is the difference between the highest and the lowest Aid flow from UN agencies (US$) of Mauritius?
Your answer should be compact. 1.11e+06. What is the difference between the highest and the lowest Aid flow from UN agencies (US$) of South Africa?
Ensure brevity in your answer.  2.55e+06. 